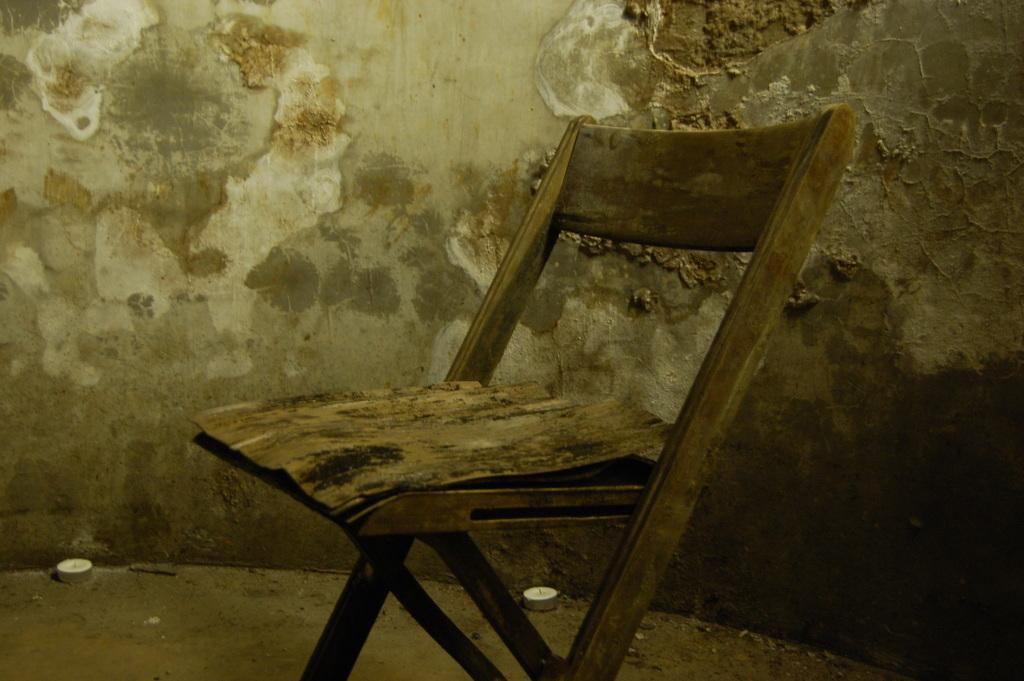What is located in the front of the image? There is a chair in the front of the image. What can be seen in the background of the image? There is a wall visible in the background of the image. How many white objects are on the ground in the image? There are two white objects on the ground in the image. What type of muscle can be seen flexing in the image? There is no muscle visible in the image. Can you describe the goat in the image? There is no goat present in the image. 